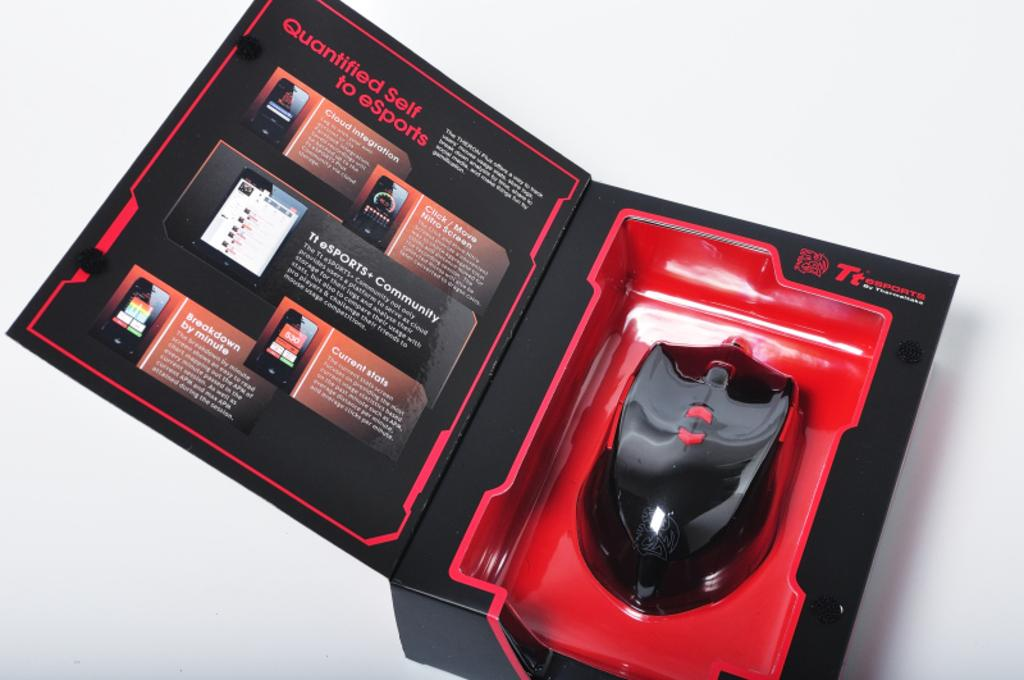What is the color of the box in the image? The box in the image is black. What is the color of the surface on which the box is placed? The surface is white. Can you describe the contrast between the box and the surface? The box and the surface have a strong contrast due to their different colors. What type of tax is being discussed in the image? There is no discussion of tax in the image; it only features a black box on a white surface. 